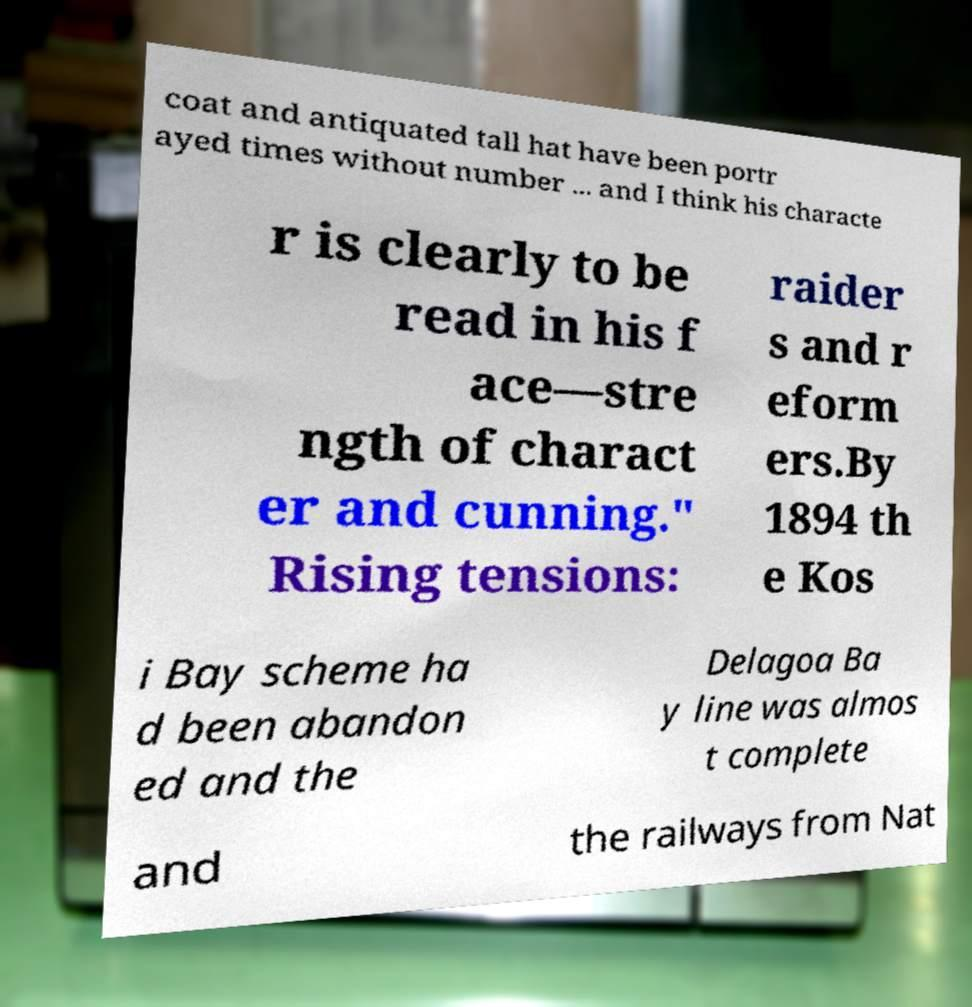I need the written content from this picture converted into text. Can you do that? coat and antiquated tall hat have been portr ayed times without number ... and I think his characte r is clearly to be read in his f ace—stre ngth of charact er and cunning." Rising tensions: raider s and r eform ers.By 1894 th e Kos i Bay scheme ha d been abandon ed and the Delagoa Ba y line was almos t complete and the railways from Nat 